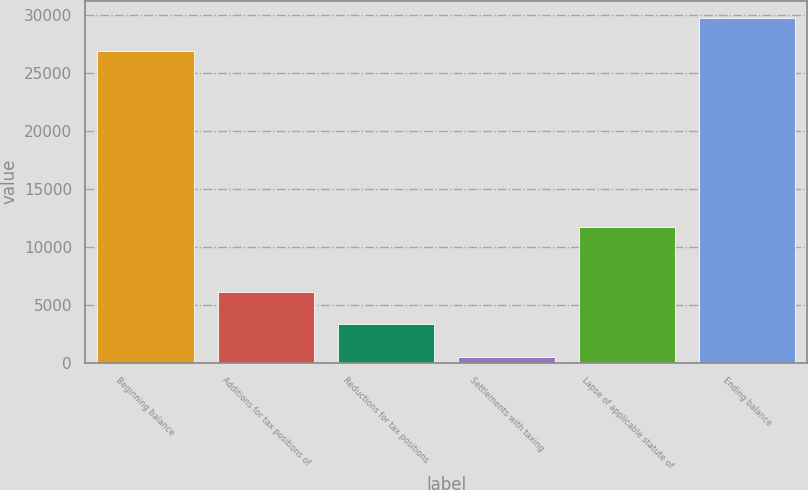Convert chart. <chart><loc_0><loc_0><loc_500><loc_500><bar_chart><fcel>Beginning balance<fcel>Additions for tax positions of<fcel>Reductions for tax positions<fcel>Settlements with taxing<fcel>Lapse of applicable statute of<fcel>Ending balance<nl><fcel>26924<fcel>6127.8<fcel>3322.9<fcel>518<fcel>11737.6<fcel>29728.9<nl></chart> 